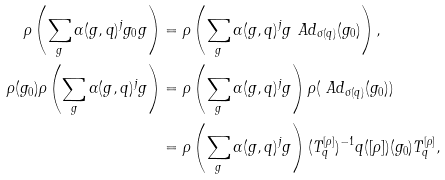Convert formula to latex. <formula><loc_0><loc_0><loc_500><loc_500>\rho \left ( \sum _ { g } \alpha ( g , q ) ^ { j } g _ { 0 } g \right ) & = \rho \left ( \sum _ { g } \alpha ( g , q ) ^ { j } g \ A d _ { \sigma ( q ) } ( g _ { 0 } ) \right ) , \\ \rho ( g _ { 0 } ) \rho \left ( \sum _ { g } \alpha ( g , q ) ^ { j } g \right ) & = \rho \left ( \sum _ { g } \alpha ( g , q ) ^ { j } g \right ) \rho ( \ A d _ { \sigma ( q ) } ( g _ { 0 } ) ) \\ & = \rho \left ( \sum _ { g } \alpha ( g , q ) ^ { j } g \right ) ( T ^ { [ \rho ] } _ { q } ) ^ { - 1 } q ( [ \rho ] ) ( g _ { 0 } ) T ^ { [ \rho ] } _ { q } ,</formula> 